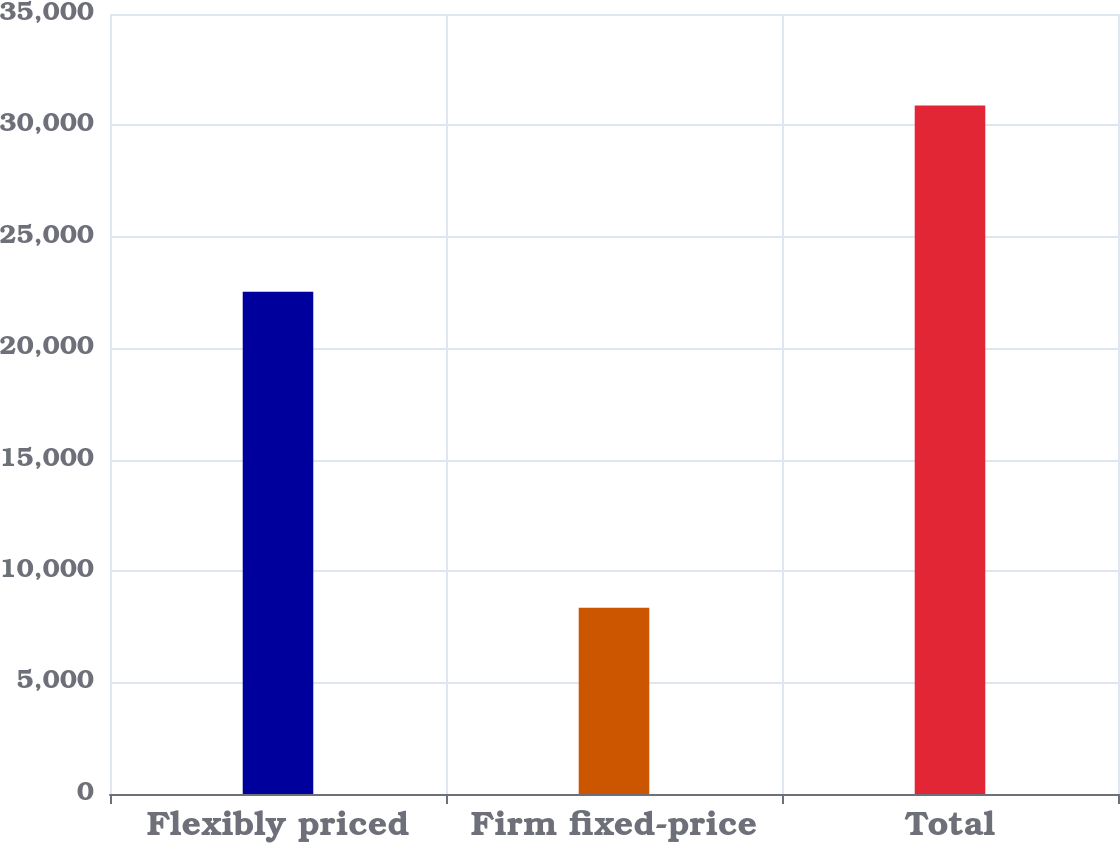Convert chart to OTSL. <chart><loc_0><loc_0><loc_500><loc_500><bar_chart><fcel>Flexibly priced<fcel>Firm fixed-price<fcel>Total<nl><fcel>22534<fcel>8358<fcel>30892<nl></chart> 